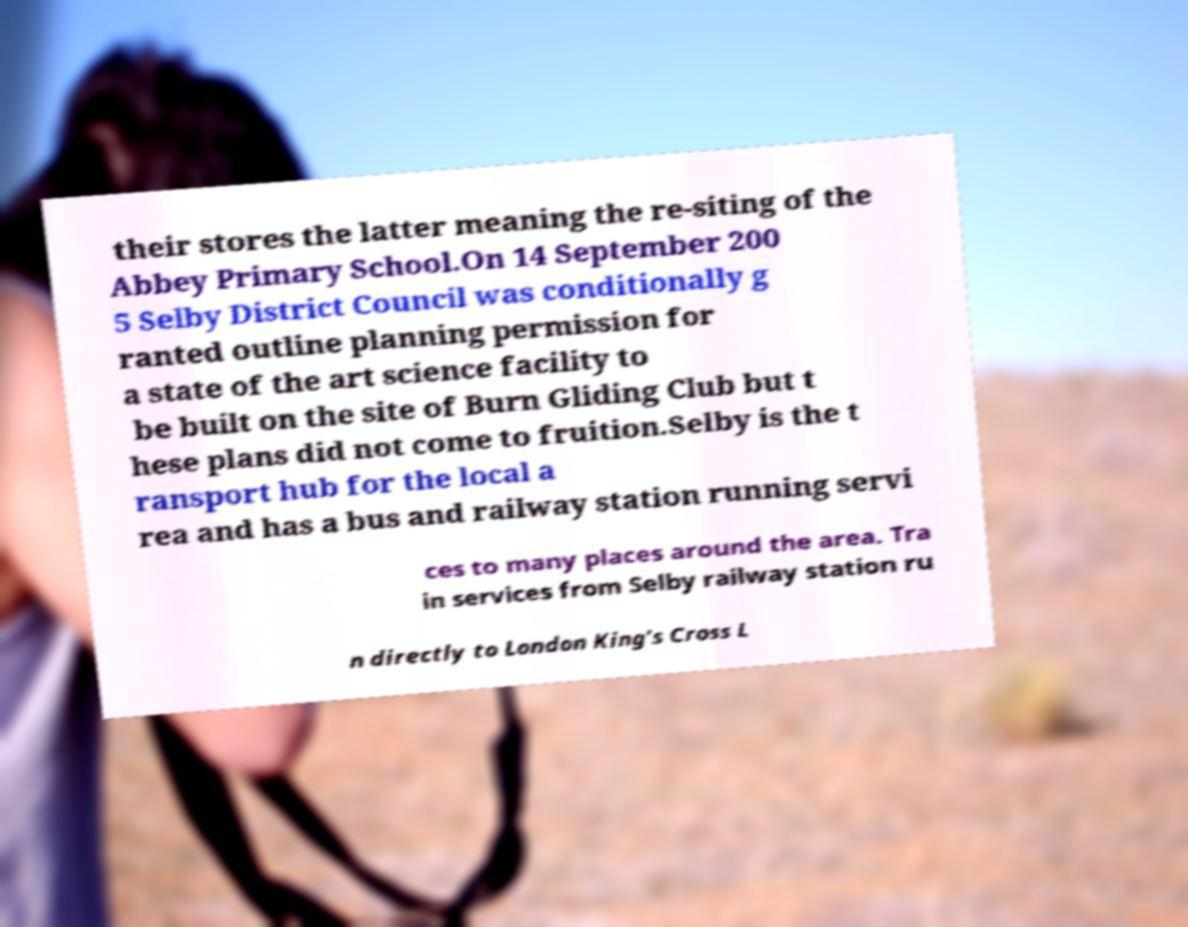Could you assist in decoding the text presented in this image and type it out clearly? their stores the latter meaning the re-siting of the Abbey Primary School.On 14 September 200 5 Selby District Council was conditionally g ranted outline planning permission for a state of the art science facility to be built on the site of Burn Gliding Club but t hese plans did not come to fruition.Selby is the t ransport hub for the local a rea and has a bus and railway station running servi ces to many places around the area. Tra in services from Selby railway station ru n directly to London King's Cross L 